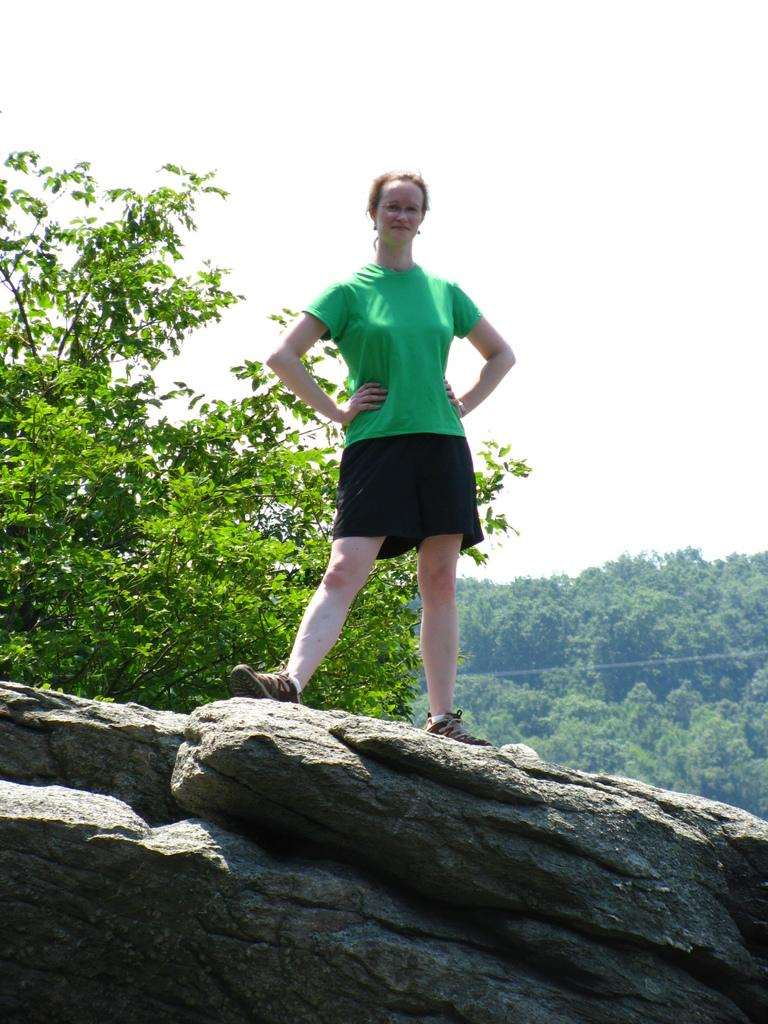What is the main subject of the picture? The main subject of the picture is a woman. What is the woman wearing on her upper body? The woman is wearing a green t-shirt. What type of clothing is the woman wearing on her lower body? The woman is wearing shorts. What type of footwear is the woman wearing? The woman is wearing shoes. Where is the woman standing in the image? The woman is standing on a stone. What can be seen in the background of the image? There are trees visible in the background. What is visible at the top of the image? The sky is visible at the top of the image. How many chickens are perched on the roof in the image? There are no chickens or roof present in the image. What type of prose is the woman reading in the image? There is no indication that the woman is reading any prose in the image. 